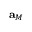<formula> <loc_0><loc_0><loc_500><loc_500>a _ { M }</formula> 